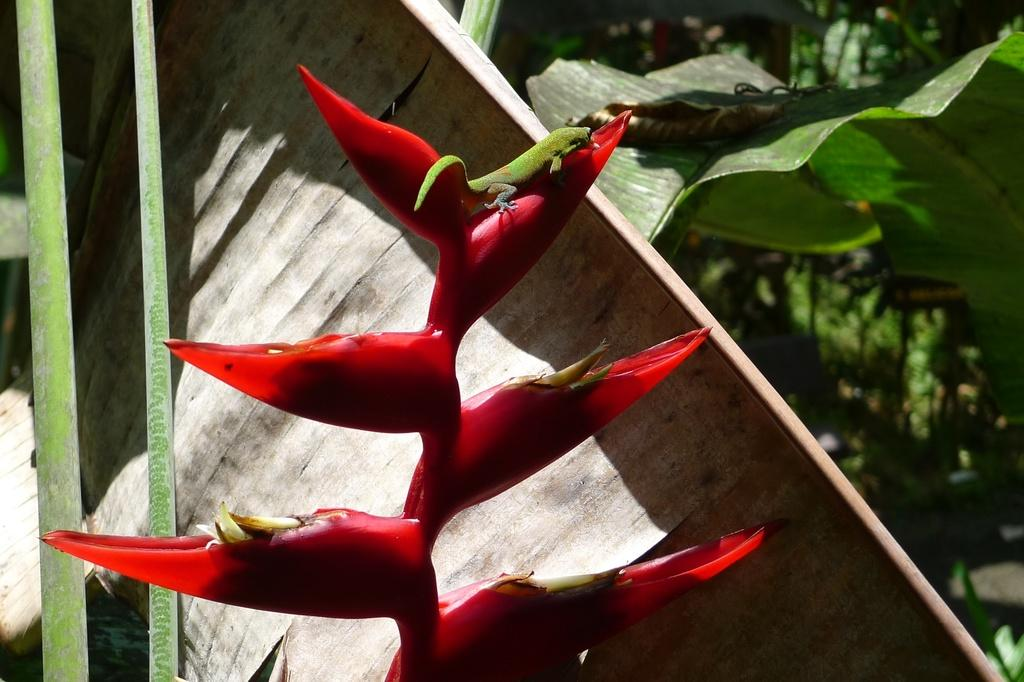What type of animal is in the image? There is a green lizard in the image. What is the lizard standing on? The lizard is standing on a red plant. What can be seen in the background of the image? There are plants and trees visible in the background of the image. What type of hair can be seen on the lizard in the image? There is no hair present on the lizard in the image, as lizards do not have hair. 